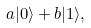Convert formula to latex. <formula><loc_0><loc_0><loc_500><loc_500>a | 0 \rangle + b | 1 \rangle ,</formula> 